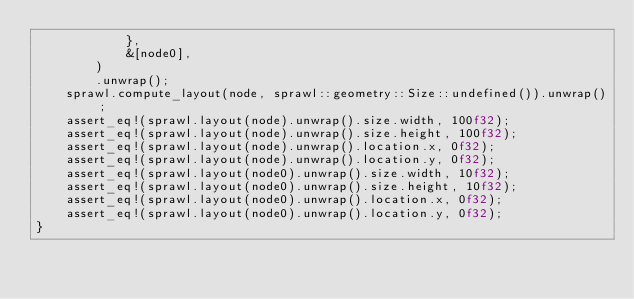Convert code to text. <code><loc_0><loc_0><loc_500><loc_500><_Rust_>            },
            &[node0],
        )
        .unwrap();
    sprawl.compute_layout(node, sprawl::geometry::Size::undefined()).unwrap();
    assert_eq!(sprawl.layout(node).unwrap().size.width, 100f32);
    assert_eq!(sprawl.layout(node).unwrap().size.height, 100f32);
    assert_eq!(sprawl.layout(node).unwrap().location.x, 0f32);
    assert_eq!(sprawl.layout(node).unwrap().location.y, 0f32);
    assert_eq!(sprawl.layout(node0).unwrap().size.width, 10f32);
    assert_eq!(sprawl.layout(node0).unwrap().size.height, 10f32);
    assert_eq!(sprawl.layout(node0).unwrap().location.x, 0f32);
    assert_eq!(sprawl.layout(node0).unwrap().location.y, 0f32);
}
</code> 